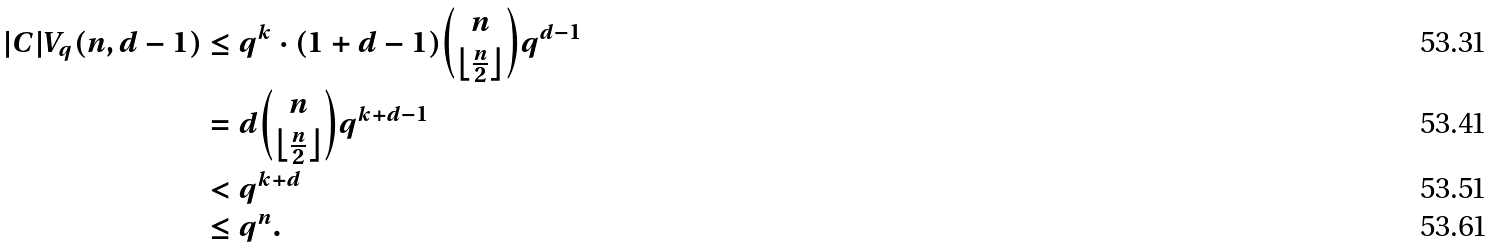<formula> <loc_0><loc_0><loc_500><loc_500>| C | V _ { q } ( n , d - 1 ) & \leq q ^ { k } \cdot ( 1 + d - 1 ) \binom { n } { \left \lfloor \frac { n } { 2 } \right \rfloor } q ^ { d - 1 } \\ & = d \binom { n } { \left \lfloor \frac { n } { 2 } \right \rfloor } q ^ { k + d - 1 } \\ & < q ^ { k + d } \\ & \leq q ^ { n } .</formula> 